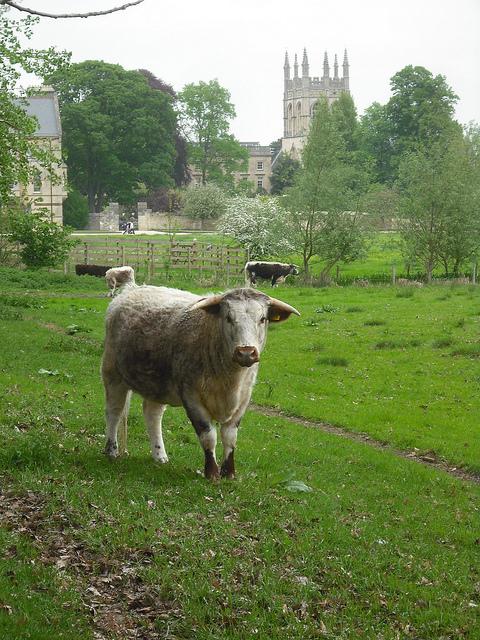What is making the darker spots in the grass?
Give a very brief answer. Dirt. What kind of animal is this?
Be succinct. Cow. Overcast or sunny?
Concise answer only. Overcast. Is there a castle in the background?
Keep it brief. Yes. 